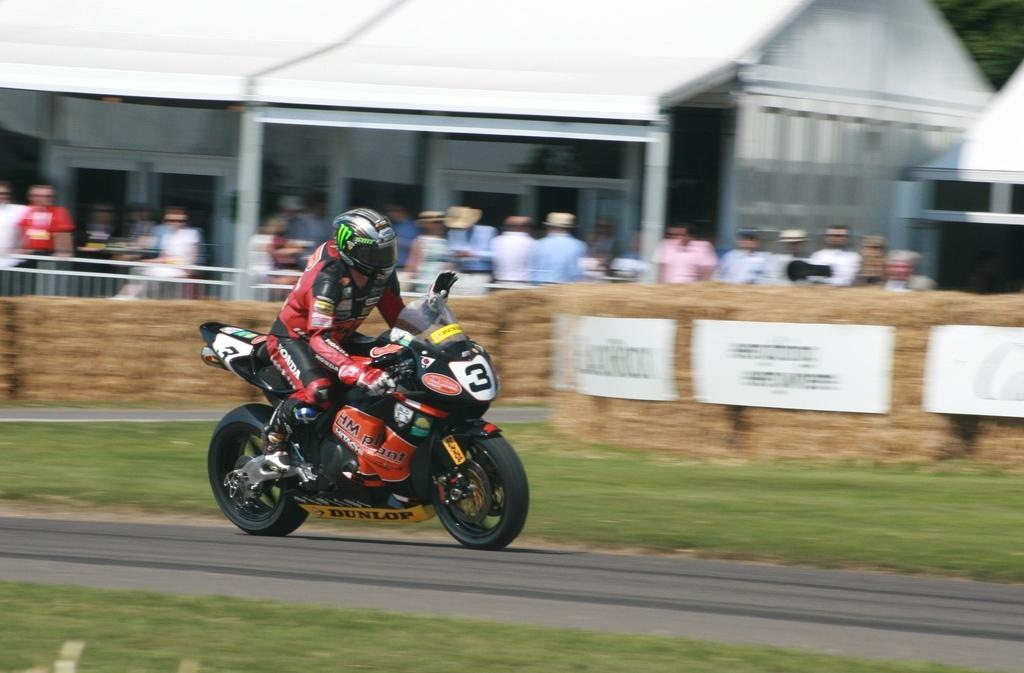What is the main subject of the image? There is a person in the image. What is the person wearing? The person is wearing a red jacket. What activity is the person engaged in? The person is riding a bike. Where is the bike located? The bike is on the road. Are there any other people in the image? Yes, there is a group of people beside the person riding the bike. What type of train can be seen in the image? There is no train present in the image; it features a person riding a bike. What color is the yarn being used by the person in the image? There is no yarn present in the image; the person is wearing a red jacket and riding a bike. 